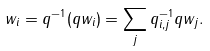Convert formula to latex. <formula><loc_0><loc_0><loc_500><loc_500>w _ { i } = q ^ { - 1 } ( q w _ { i } ) = \sum _ { j } q ^ { - 1 } _ { i , j } q w _ { j } .</formula> 